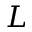<formula> <loc_0><loc_0><loc_500><loc_500>L</formula> 